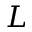<formula> <loc_0><loc_0><loc_500><loc_500>L</formula> 